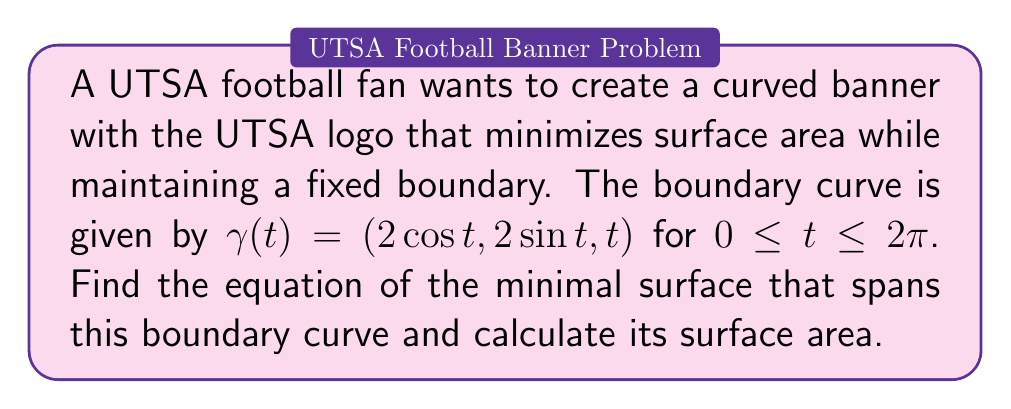Provide a solution to this math problem. To find the minimal surface area for the UTSA logo on a curved banner, we need to solve the minimal surface equation and calculate its area. Let's approach this step-by-step:

1) The minimal surface equation in cylindrical coordinates $(r, \theta, z)$ is:

   $$ \frac{\partial}{\partial r}\left(r\frac{\partial z}{\partial r}\right) + \frac{\partial^2 z}{\partial \theta^2} = 0 $$

2) Given the boundary curve $\gamma(t) = (2\cos t, 2\sin t, t)$, we can guess that the solution has the form:

   $$ z(r, \theta) = a\theta $$

   where $a$ is a constant to be determined.

3) Substituting this into the minimal surface equation:

   $$ \frac{\partial}{\partial r}\left(r\frac{\partial (a\theta)}{\partial r}\right) + \frac{\partial^2 (a\theta)}{\partial \theta^2} = 0 $$

   $$ 0 + 0 = 0 $$

   This satisfies the equation for any value of $a$.

4) To determine $a$, we use the boundary condition. At $r = 2$, $z = t = \theta$, so:

   $$ a\theta = \theta $$

   Therefore, $a = 1$.

5) The equation of the minimal surface is:

   $$ z(r, \theta) = \theta $$

6) To calculate the surface area, we use the surface area formula in cylindrical coordinates:

   $$ A = \int_0^{2\pi} \int_0^2 r\sqrt{1 + \left(\frac{\partial z}{\partial r}\right)^2 + \frac{1}{r^2}\left(\frac{\partial z}{\partial \theta}\right)^2} dr d\theta $$

7) Substituting $z = \theta$:

   $$ A = \int_0^{2\pi} \int_0^2 r\sqrt{1 + 0^2 + \frac{1}{r^2}(1)^2} dr d\theta $$

   $$ A = \int_0^{2\pi} \int_0^2 \sqrt{r^2 + 1} dr d\theta $$

8) Evaluating the integral:

   $$ A = 2\pi \left[\frac{1}{2}r\sqrt{r^2 + 1} + \frac{1}{2}\ln(r + \sqrt{r^2 + 1})\right]_0^2 $$

   $$ A = 2\pi \left[2\sqrt{5} + \frac{1}{2}\ln(2 + \sqrt{5})\right] $$

Thus, we have found the equation of the minimal surface and its surface area.
Answer: $z = \theta$; Area $= 2\pi [2\sqrt{5} + \frac{1}{2}\ln(2 + \sqrt{5})]$ 